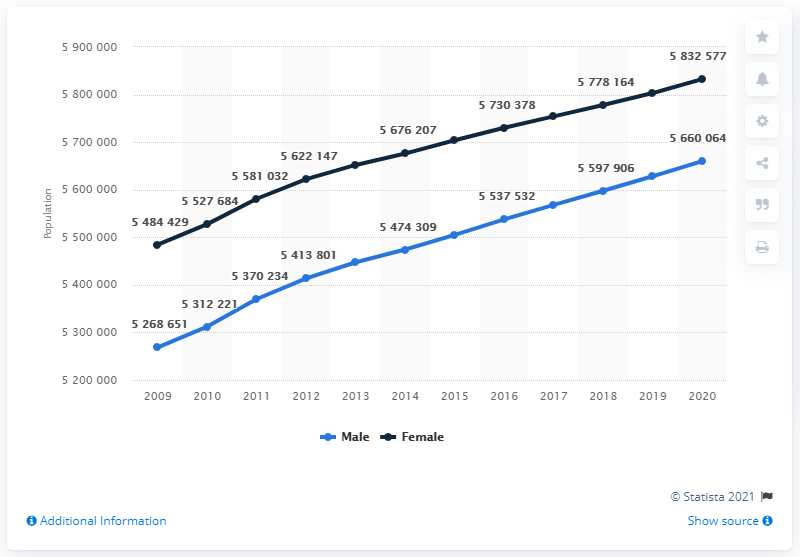Outline some significant characteristics in this image. In 2009, there were 5312221 male inhabitants in Belgium. The highest population for females is 56,600,641. In 2020, the population difference between males and females was approximately 172,513. In 2019, there were 553,7532 male inhabitants in Belgium. 